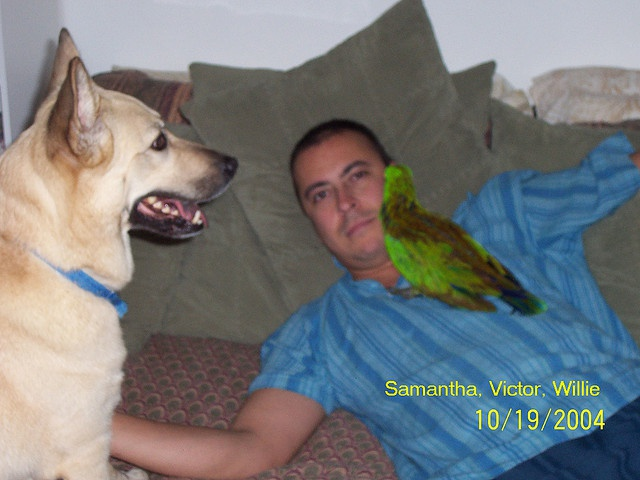Describe the objects in this image and their specific colors. I can see couch in darkgray, gray, and black tones, people in darkgray, blue, gray, and brown tones, dog in darkgray, tan, and lightgray tones, and bird in darkgray, darkgreen, black, and green tones in this image. 